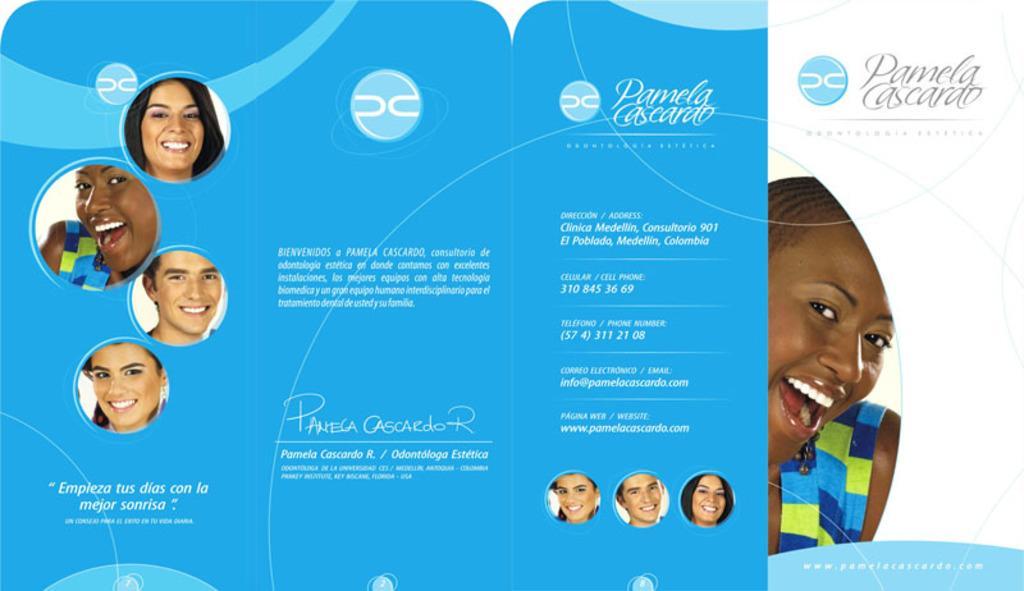In one or two sentences, can you explain what this image depicts? In this image there is a poster. There are picture of a few people and text on the poster. 